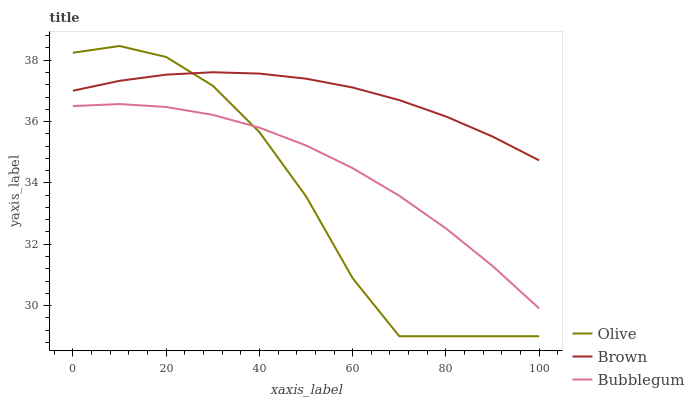Does Bubblegum have the minimum area under the curve?
Answer yes or no. No. Does Bubblegum have the maximum area under the curve?
Answer yes or no. No. Is Bubblegum the smoothest?
Answer yes or no. No. Is Bubblegum the roughest?
Answer yes or no. No. Does Bubblegum have the lowest value?
Answer yes or no. No. Does Brown have the highest value?
Answer yes or no. No. Is Bubblegum less than Brown?
Answer yes or no. Yes. Is Brown greater than Bubblegum?
Answer yes or no. Yes. Does Bubblegum intersect Brown?
Answer yes or no. No. 